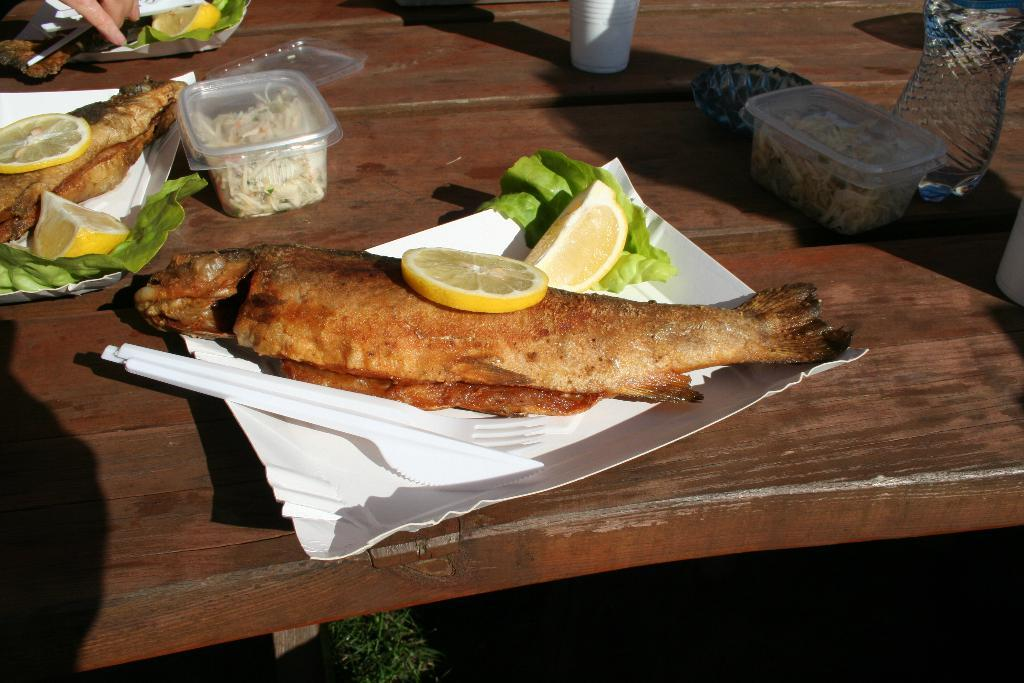What are the eatables placed on in the image? The eatables are placed on white paper plates. What else is placed beside the eatables? There are drinks placed beside the eatables. What is the color of the table in the image? The table is brown. What type of suit is the authority figure wearing in the image? There is no authority figure or suit present in the image. Is there a turkey visible in the image? No, there is no turkey present in the image. 